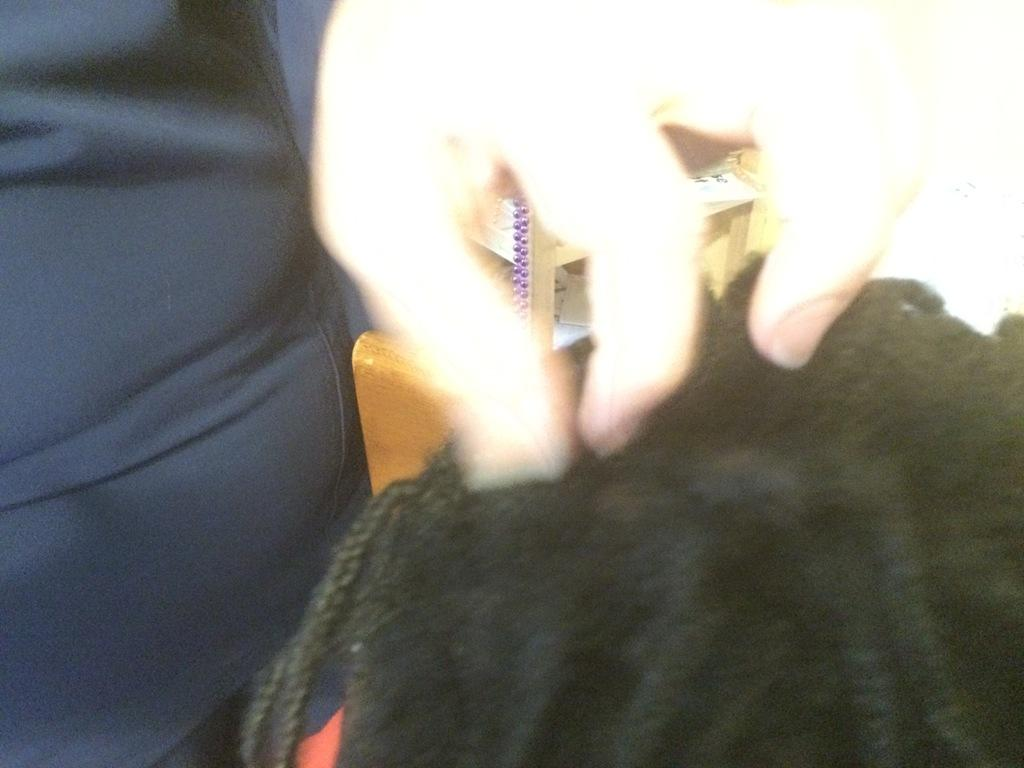What is the position of the person in the image? There is a person standing on the left side of the image. Can you describe the other person in the image? A man's head is visible on the right side of the image. What can be seen in the background of the image? There are objects in the background of the image. How many pigs are visible in the image? There are no pigs present in the image. What type of cream is being used by the person on the left side of the image? There is no cream visible in the image, and the person on the left is not using any cream. 